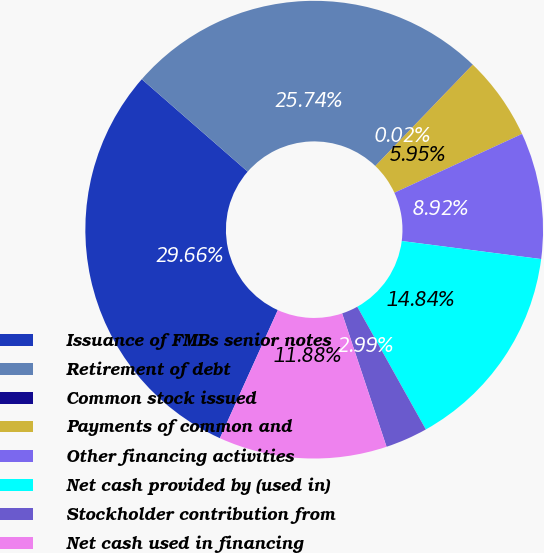Convert chart to OTSL. <chart><loc_0><loc_0><loc_500><loc_500><pie_chart><fcel>Issuance of FMBs senior notes<fcel>Retirement of debt<fcel>Common stock issued<fcel>Payments of common and<fcel>Other financing activities<fcel>Net cash provided by (used in)<fcel>Stockholder contribution from<fcel>Net cash used in financing<nl><fcel>29.66%<fcel>25.74%<fcel>0.02%<fcel>5.95%<fcel>8.92%<fcel>14.84%<fcel>2.99%<fcel>11.88%<nl></chart> 